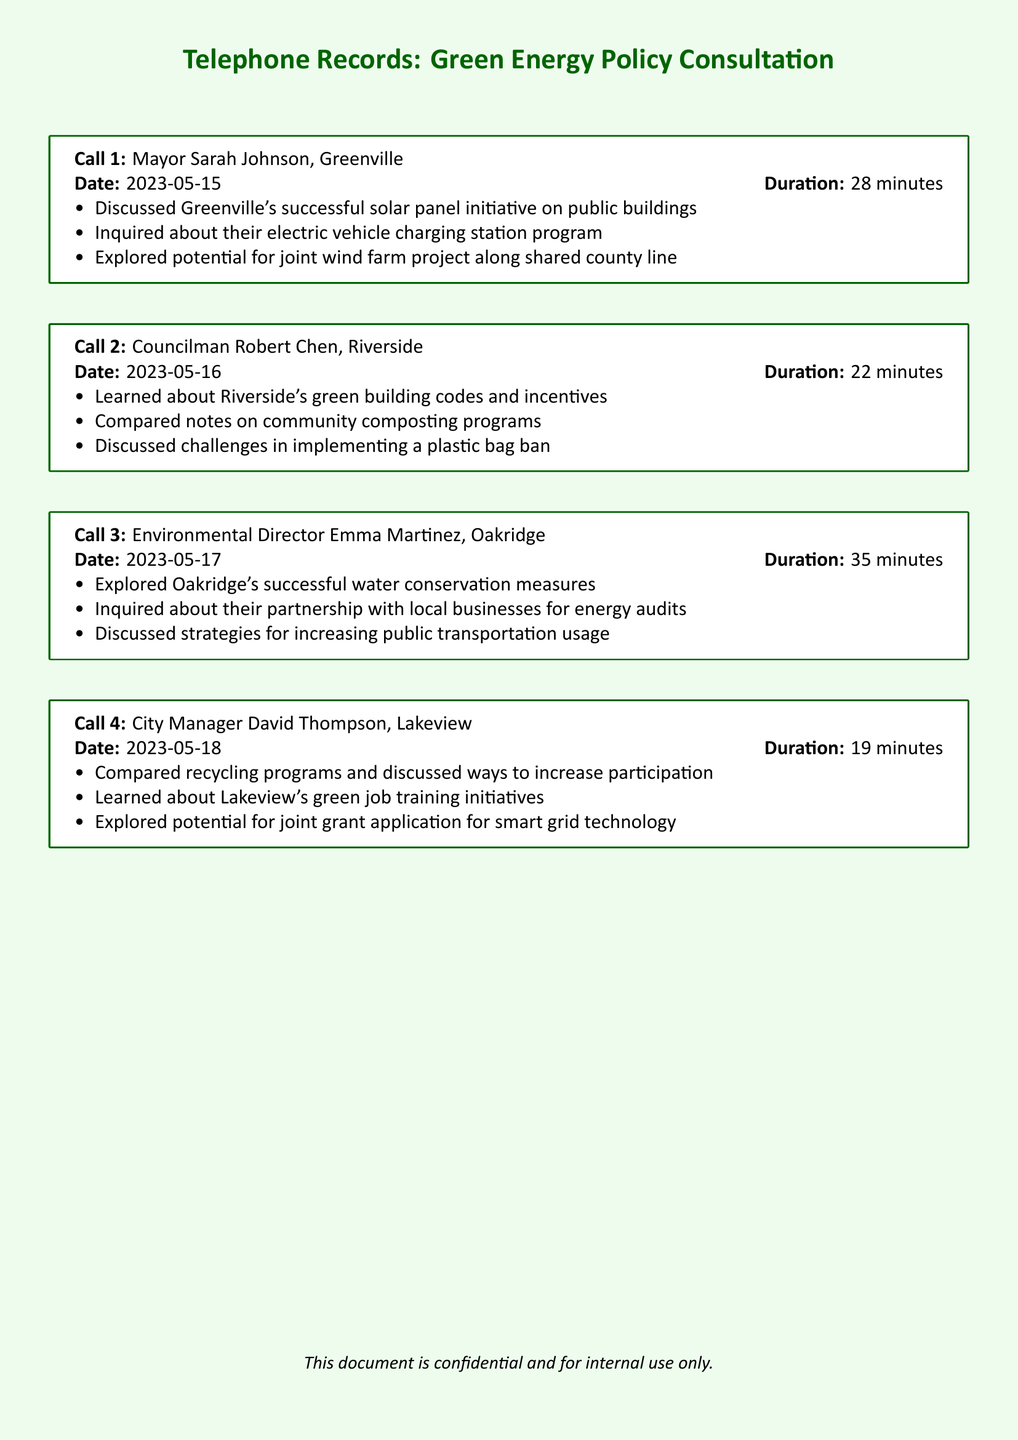What is the date of the call with Mayor Sarah Johnson? The document states the date of the call with Mayor Sarah Johnson as 2023-05-15.
Answer: 2023-05-15 How long did the conversation with Councilman Robert Chen last? The duration of the call with Councilman Robert Chen is listed as 22 minutes.
Answer: 22 minutes What initiative did Greenville discuss in Call 1? The document mentions that Greenville discussed a successful solar panel initiative on public buildings.
Answer: solar panel initiative Which city is associated with the call on 2023-05-17? The call on 2023-05-17 is with Environmental Director Emma Martinez from Oakridge.
Answer: Oakridge What type of program did Riverside compare notes on? The document indicates that Riverside and another city compared notes on community composting programs.
Answer: community composting programs What was discussed regarding Lakeview in Call 4? The discussion included Lakeview's green job training initiatives as per the call record.
Answer: green job training initiatives How many calls were made in total? The document lists a total of four calls made to different city officials.
Answer: four Which city did not discuss strategies related to public transportation? According to the document, Greenville did not discuss public transportation strategies; that was discussed by Oakridge.
Answer: Greenville What was the main purpose of the call with City Manager David Thompson? The call with City Manager David Thompson primarily compared recycling programs and ways to increase participation.
Answer: compare recycling programs 